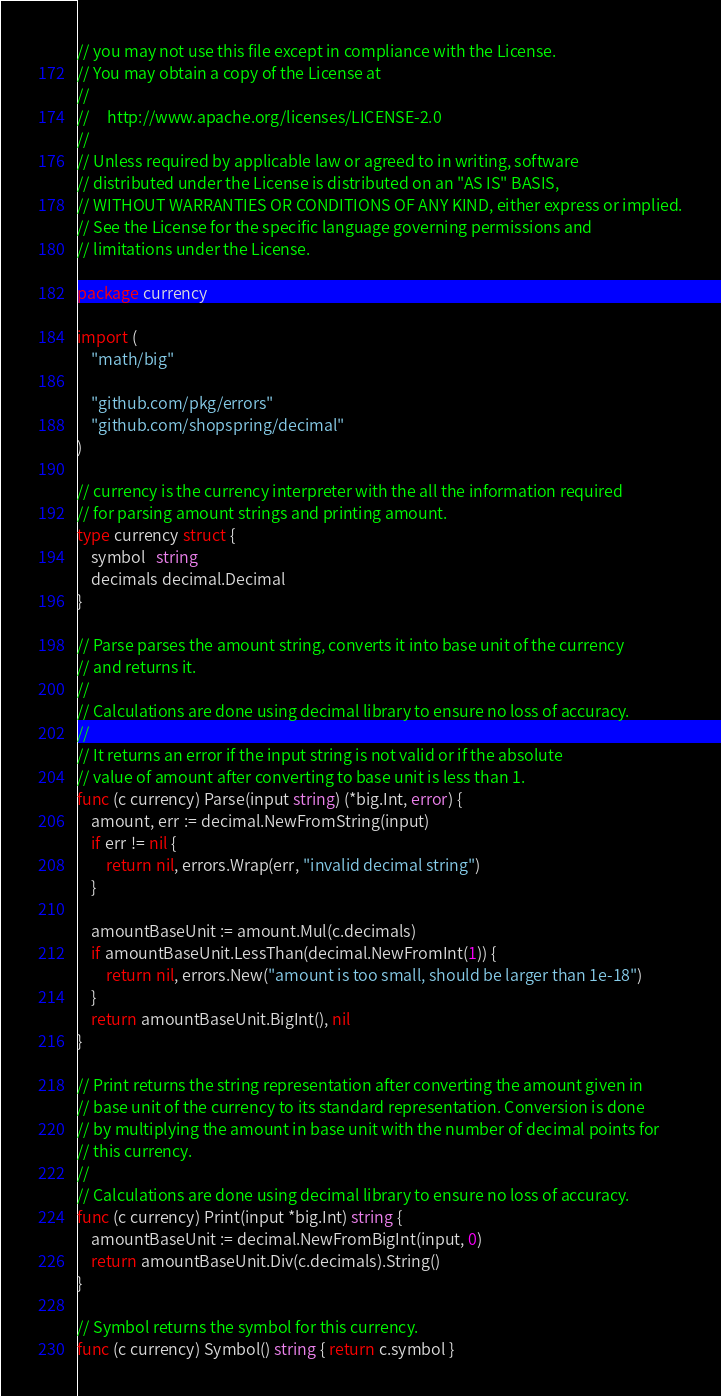Convert code to text. <code><loc_0><loc_0><loc_500><loc_500><_Go_>// you may not use this file except in compliance with the License.
// You may obtain a copy of the License at
//
//     http://www.apache.org/licenses/LICENSE-2.0
//
// Unless required by applicable law or agreed to in writing, software
// distributed under the License is distributed on an "AS IS" BASIS,
// WITHOUT WARRANTIES OR CONDITIONS OF ANY KIND, either express or implied.
// See the License for the specific language governing permissions and
// limitations under the License.

package currency

import (
	"math/big"

	"github.com/pkg/errors"
	"github.com/shopspring/decimal"
)

// currency is the currency interpreter with the all the information required
// for parsing amount strings and printing amount.
type currency struct {
	symbol   string
	decimals decimal.Decimal
}

// Parse parses the amount string, converts it into base unit of the currency
// and returns it.
//
// Calculations are done using decimal library to ensure no loss of accuracy.
//
// It returns an error if the input string is not valid or if the absolute
// value of amount after converting to base unit is less than 1.
func (c currency) Parse(input string) (*big.Int, error) {
	amount, err := decimal.NewFromString(input)
	if err != nil {
		return nil, errors.Wrap(err, "invalid decimal string")
	}

	amountBaseUnit := amount.Mul(c.decimals)
	if amountBaseUnit.LessThan(decimal.NewFromInt(1)) {
		return nil, errors.New("amount is too small, should be larger than 1e-18")
	}
	return amountBaseUnit.BigInt(), nil
}

// Print returns the string representation after converting the amount given in
// base unit of the currency to its standard representation. Conversion is done
// by multiplying the amount in base unit with the number of decimal points for
// this currency.
//
// Calculations are done using decimal library to ensure no loss of accuracy.
func (c currency) Print(input *big.Int) string {
	amountBaseUnit := decimal.NewFromBigInt(input, 0)
	return amountBaseUnit.Div(c.decimals).String()
}

// Symbol returns the symbol for this currency.
func (c currency) Symbol() string { return c.symbol }
</code> 